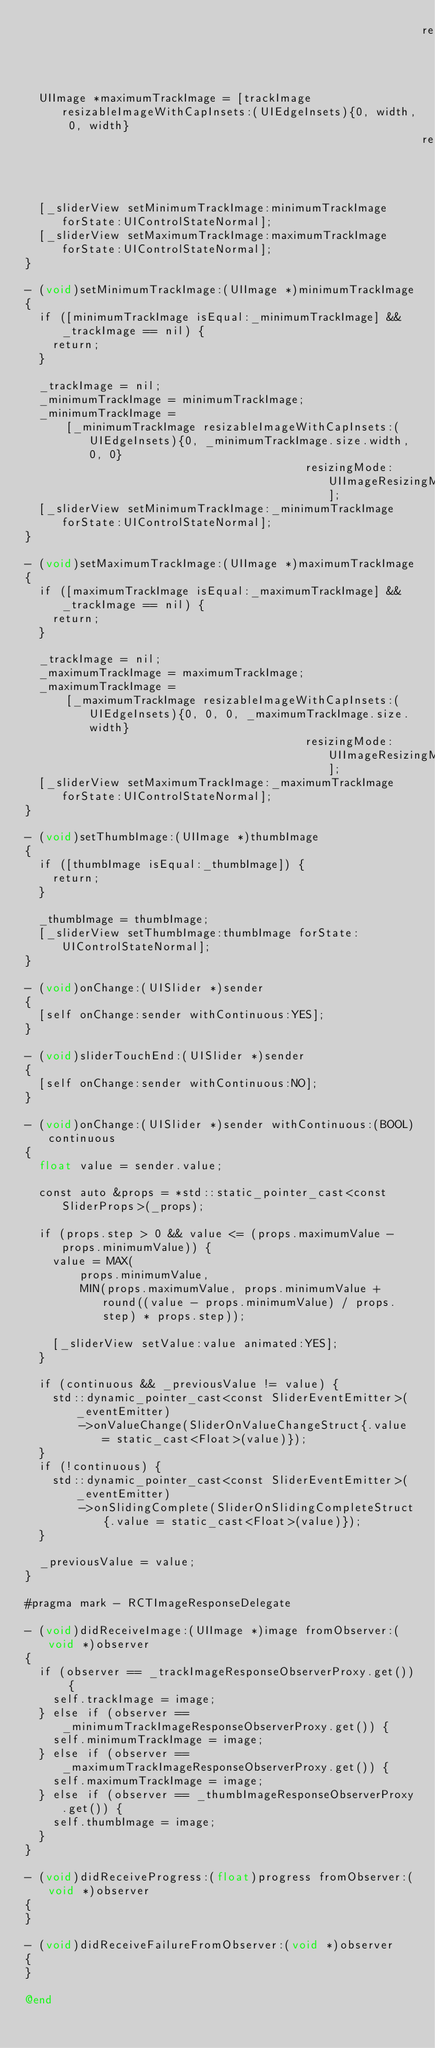Convert code to text. <code><loc_0><loc_0><loc_500><loc_500><_ObjectiveC_>                                                          resizingMode:UIImageResizingModeStretch];
  UIImage *maximumTrackImage = [trackImage resizableImageWithCapInsets:(UIEdgeInsets){0, width, 0, width}
                                                          resizingMode:UIImageResizingModeStretch];
  [_sliderView setMinimumTrackImage:minimumTrackImage forState:UIControlStateNormal];
  [_sliderView setMaximumTrackImage:maximumTrackImage forState:UIControlStateNormal];
}

- (void)setMinimumTrackImage:(UIImage *)minimumTrackImage
{
  if ([minimumTrackImage isEqual:_minimumTrackImage] && _trackImage == nil) {
    return;
  }

  _trackImage = nil;
  _minimumTrackImage = minimumTrackImage;
  _minimumTrackImage =
      [_minimumTrackImage resizableImageWithCapInsets:(UIEdgeInsets){0, _minimumTrackImage.size.width, 0, 0}
                                         resizingMode:UIImageResizingModeStretch];
  [_sliderView setMinimumTrackImage:_minimumTrackImage forState:UIControlStateNormal];
}

- (void)setMaximumTrackImage:(UIImage *)maximumTrackImage
{
  if ([maximumTrackImage isEqual:_maximumTrackImage] && _trackImage == nil) {
    return;
  }

  _trackImage = nil;
  _maximumTrackImage = maximumTrackImage;
  _maximumTrackImage =
      [_maximumTrackImage resizableImageWithCapInsets:(UIEdgeInsets){0, 0, 0, _maximumTrackImage.size.width}
                                         resizingMode:UIImageResizingModeStretch];
  [_sliderView setMaximumTrackImage:_maximumTrackImage forState:UIControlStateNormal];
}

- (void)setThumbImage:(UIImage *)thumbImage
{
  if ([thumbImage isEqual:_thumbImage]) {
    return;
  }

  _thumbImage = thumbImage;
  [_sliderView setThumbImage:thumbImage forState:UIControlStateNormal];
}

- (void)onChange:(UISlider *)sender
{
  [self onChange:sender withContinuous:YES];
}

- (void)sliderTouchEnd:(UISlider *)sender
{
  [self onChange:sender withContinuous:NO];
}

- (void)onChange:(UISlider *)sender withContinuous:(BOOL)continuous
{
  float value = sender.value;

  const auto &props = *std::static_pointer_cast<const SliderProps>(_props);

  if (props.step > 0 && value <= (props.maximumValue - props.minimumValue)) {
    value = MAX(
        props.minimumValue,
        MIN(props.maximumValue, props.minimumValue + round((value - props.minimumValue) / props.step) * props.step));

    [_sliderView setValue:value animated:YES];
  }

  if (continuous && _previousValue != value) {
    std::dynamic_pointer_cast<const SliderEventEmitter>(_eventEmitter)
        ->onValueChange(SliderOnValueChangeStruct{.value = static_cast<Float>(value)});
  }
  if (!continuous) {
    std::dynamic_pointer_cast<const SliderEventEmitter>(_eventEmitter)
        ->onSlidingComplete(SliderOnSlidingCompleteStruct{.value = static_cast<Float>(value)});
  }

  _previousValue = value;
}

#pragma mark - RCTImageResponseDelegate

- (void)didReceiveImage:(UIImage *)image fromObserver:(void *)observer
{
  if (observer == _trackImageResponseObserverProxy.get()) {
    self.trackImage = image;
  } else if (observer == _minimumTrackImageResponseObserverProxy.get()) {
    self.minimumTrackImage = image;
  } else if (observer == _maximumTrackImageResponseObserverProxy.get()) {
    self.maximumTrackImage = image;
  } else if (observer == _thumbImageResponseObserverProxy.get()) {
    self.thumbImage = image;
  }
}

- (void)didReceiveProgress:(float)progress fromObserver:(void *)observer
{
}

- (void)didReceiveFailureFromObserver:(void *)observer
{
}

@end
</code> 